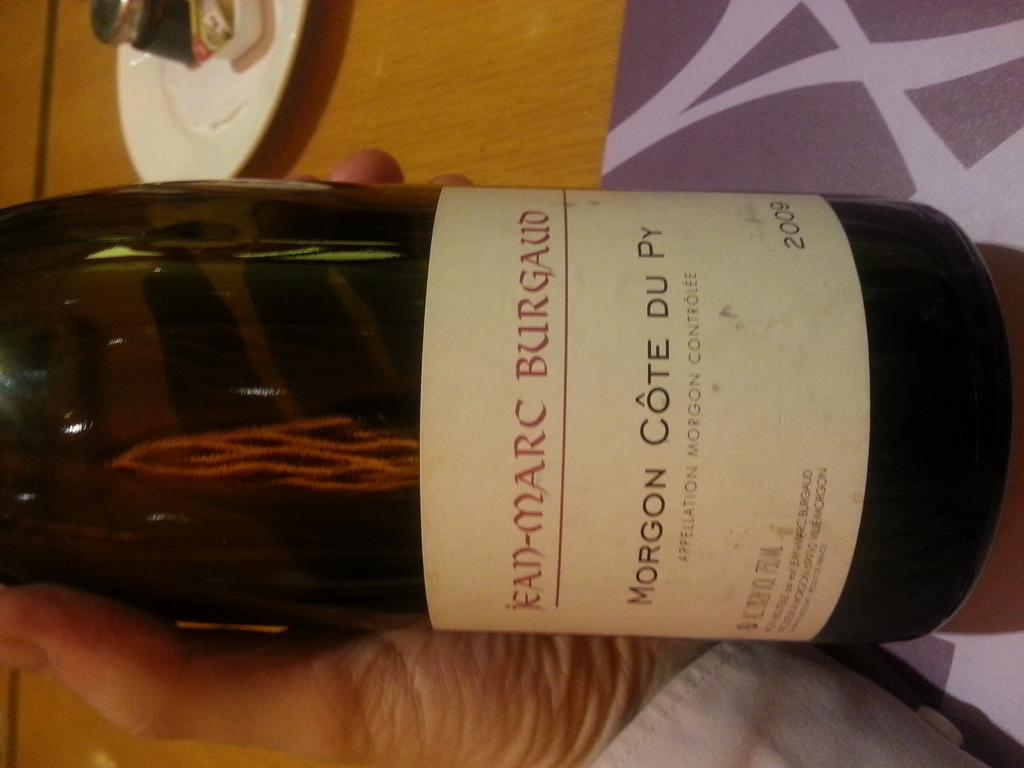<image>
Give a short and clear explanation of the subsequent image. A label on the bottle says Morgon Cote du py. 